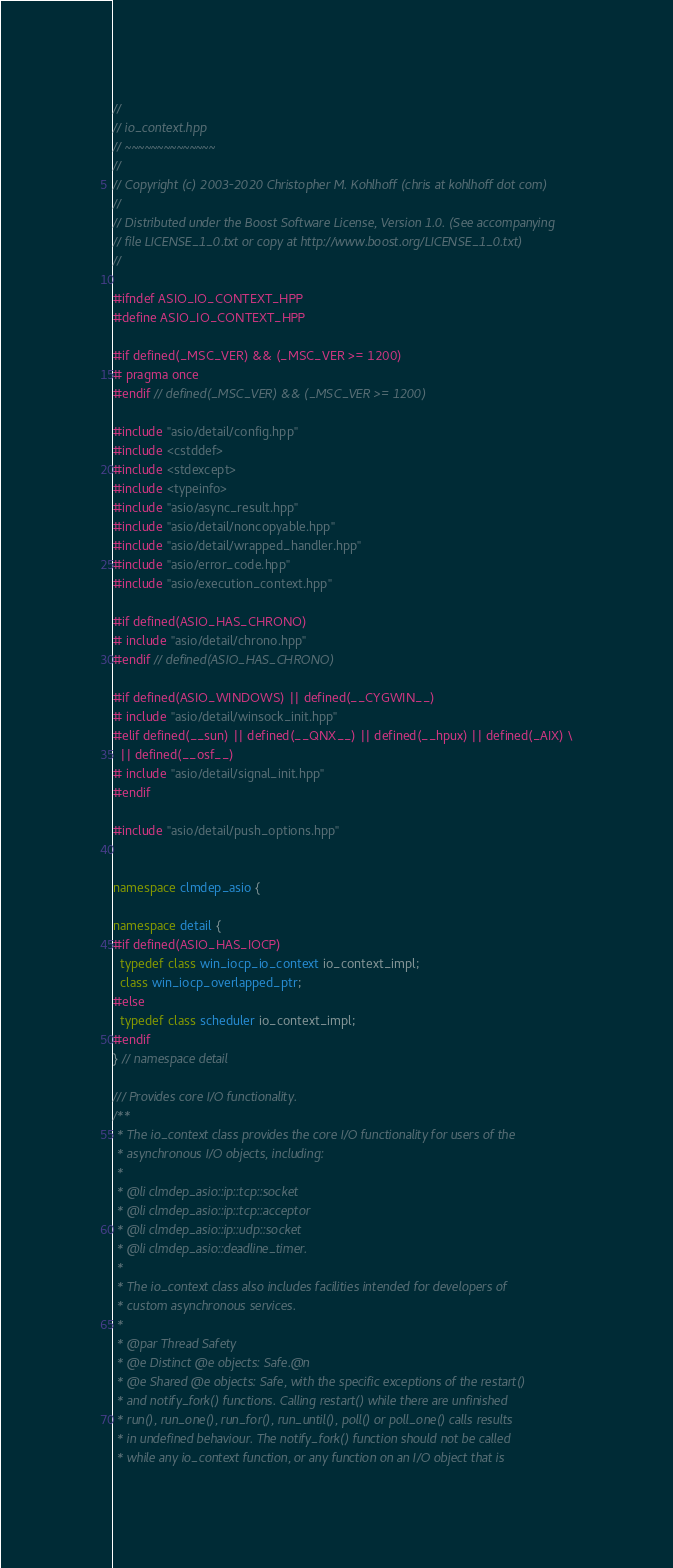Convert code to text. <code><loc_0><loc_0><loc_500><loc_500><_C++_>//
// io_context.hpp
// ~~~~~~~~~~~~~~
//
// Copyright (c) 2003-2020 Christopher M. Kohlhoff (chris at kohlhoff dot com)
//
// Distributed under the Boost Software License, Version 1.0. (See accompanying
// file LICENSE_1_0.txt or copy at http://www.boost.org/LICENSE_1_0.txt)
//

#ifndef ASIO_IO_CONTEXT_HPP
#define ASIO_IO_CONTEXT_HPP

#if defined(_MSC_VER) && (_MSC_VER >= 1200)
# pragma once
#endif // defined(_MSC_VER) && (_MSC_VER >= 1200)

#include "asio/detail/config.hpp"
#include <cstddef>
#include <stdexcept>
#include <typeinfo>
#include "asio/async_result.hpp"
#include "asio/detail/noncopyable.hpp"
#include "asio/detail/wrapped_handler.hpp"
#include "asio/error_code.hpp"
#include "asio/execution_context.hpp"

#if defined(ASIO_HAS_CHRONO)
# include "asio/detail/chrono.hpp"
#endif // defined(ASIO_HAS_CHRONO)

#if defined(ASIO_WINDOWS) || defined(__CYGWIN__)
# include "asio/detail/winsock_init.hpp"
#elif defined(__sun) || defined(__QNX__) || defined(__hpux) || defined(_AIX) \
  || defined(__osf__)
# include "asio/detail/signal_init.hpp"
#endif

#include "asio/detail/push_options.hpp"


namespace clmdep_asio {

namespace detail {
#if defined(ASIO_HAS_IOCP)
  typedef class win_iocp_io_context io_context_impl;
  class win_iocp_overlapped_ptr;
#else
  typedef class scheduler io_context_impl;
#endif
} // namespace detail

/// Provides core I/O functionality.
/**
 * The io_context class provides the core I/O functionality for users of the
 * asynchronous I/O objects, including:
 *
 * @li clmdep_asio::ip::tcp::socket
 * @li clmdep_asio::ip::tcp::acceptor
 * @li clmdep_asio::ip::udp::socket
 * @li clmdep_asio::deadline_timer.
 *
 * The io_context class also includes facilities intended for developers of
 * custom asynchronous services.
 *
 * @par Thread Safety
 * @e Distinct @e objects: Safe.@n
 * @e Shared @e objects: Safe, with the specific exceptions of the restart()
 * and notify_fork() functions. Calling restart() while there are unfinished
 * run(), run_one(), run_for(), run_until(), poll() or poll_one() calls results
 * in undefined behaviour. The notify_fork() function should not be called
 * while any io_context function, or any function on an I/O object that is</code> 